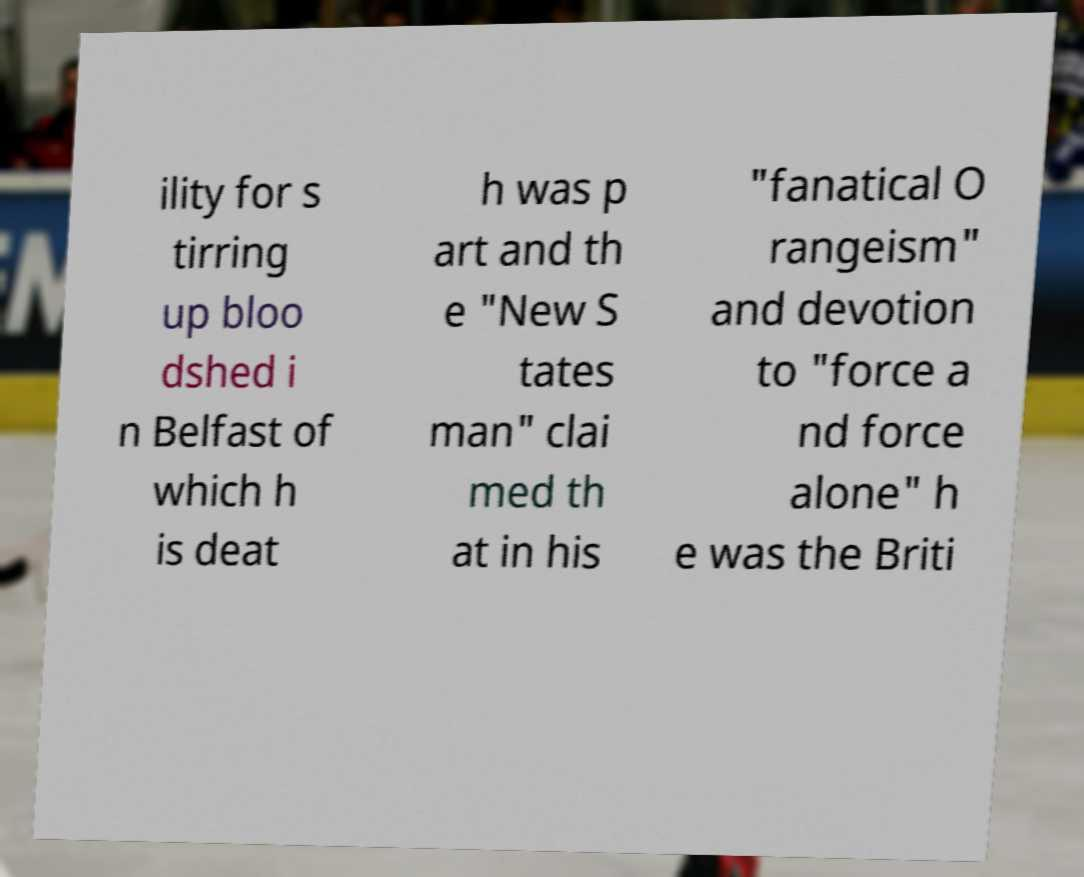Please identify and transcribe the text found in this image. ility for s tirring up bloo dshed i n Belfast of which h is deat h was p art and th e "New S tates man" clai med th at in his "fanatical O rangeism" and devotion to "force a nd force alone" h e was the Briti 